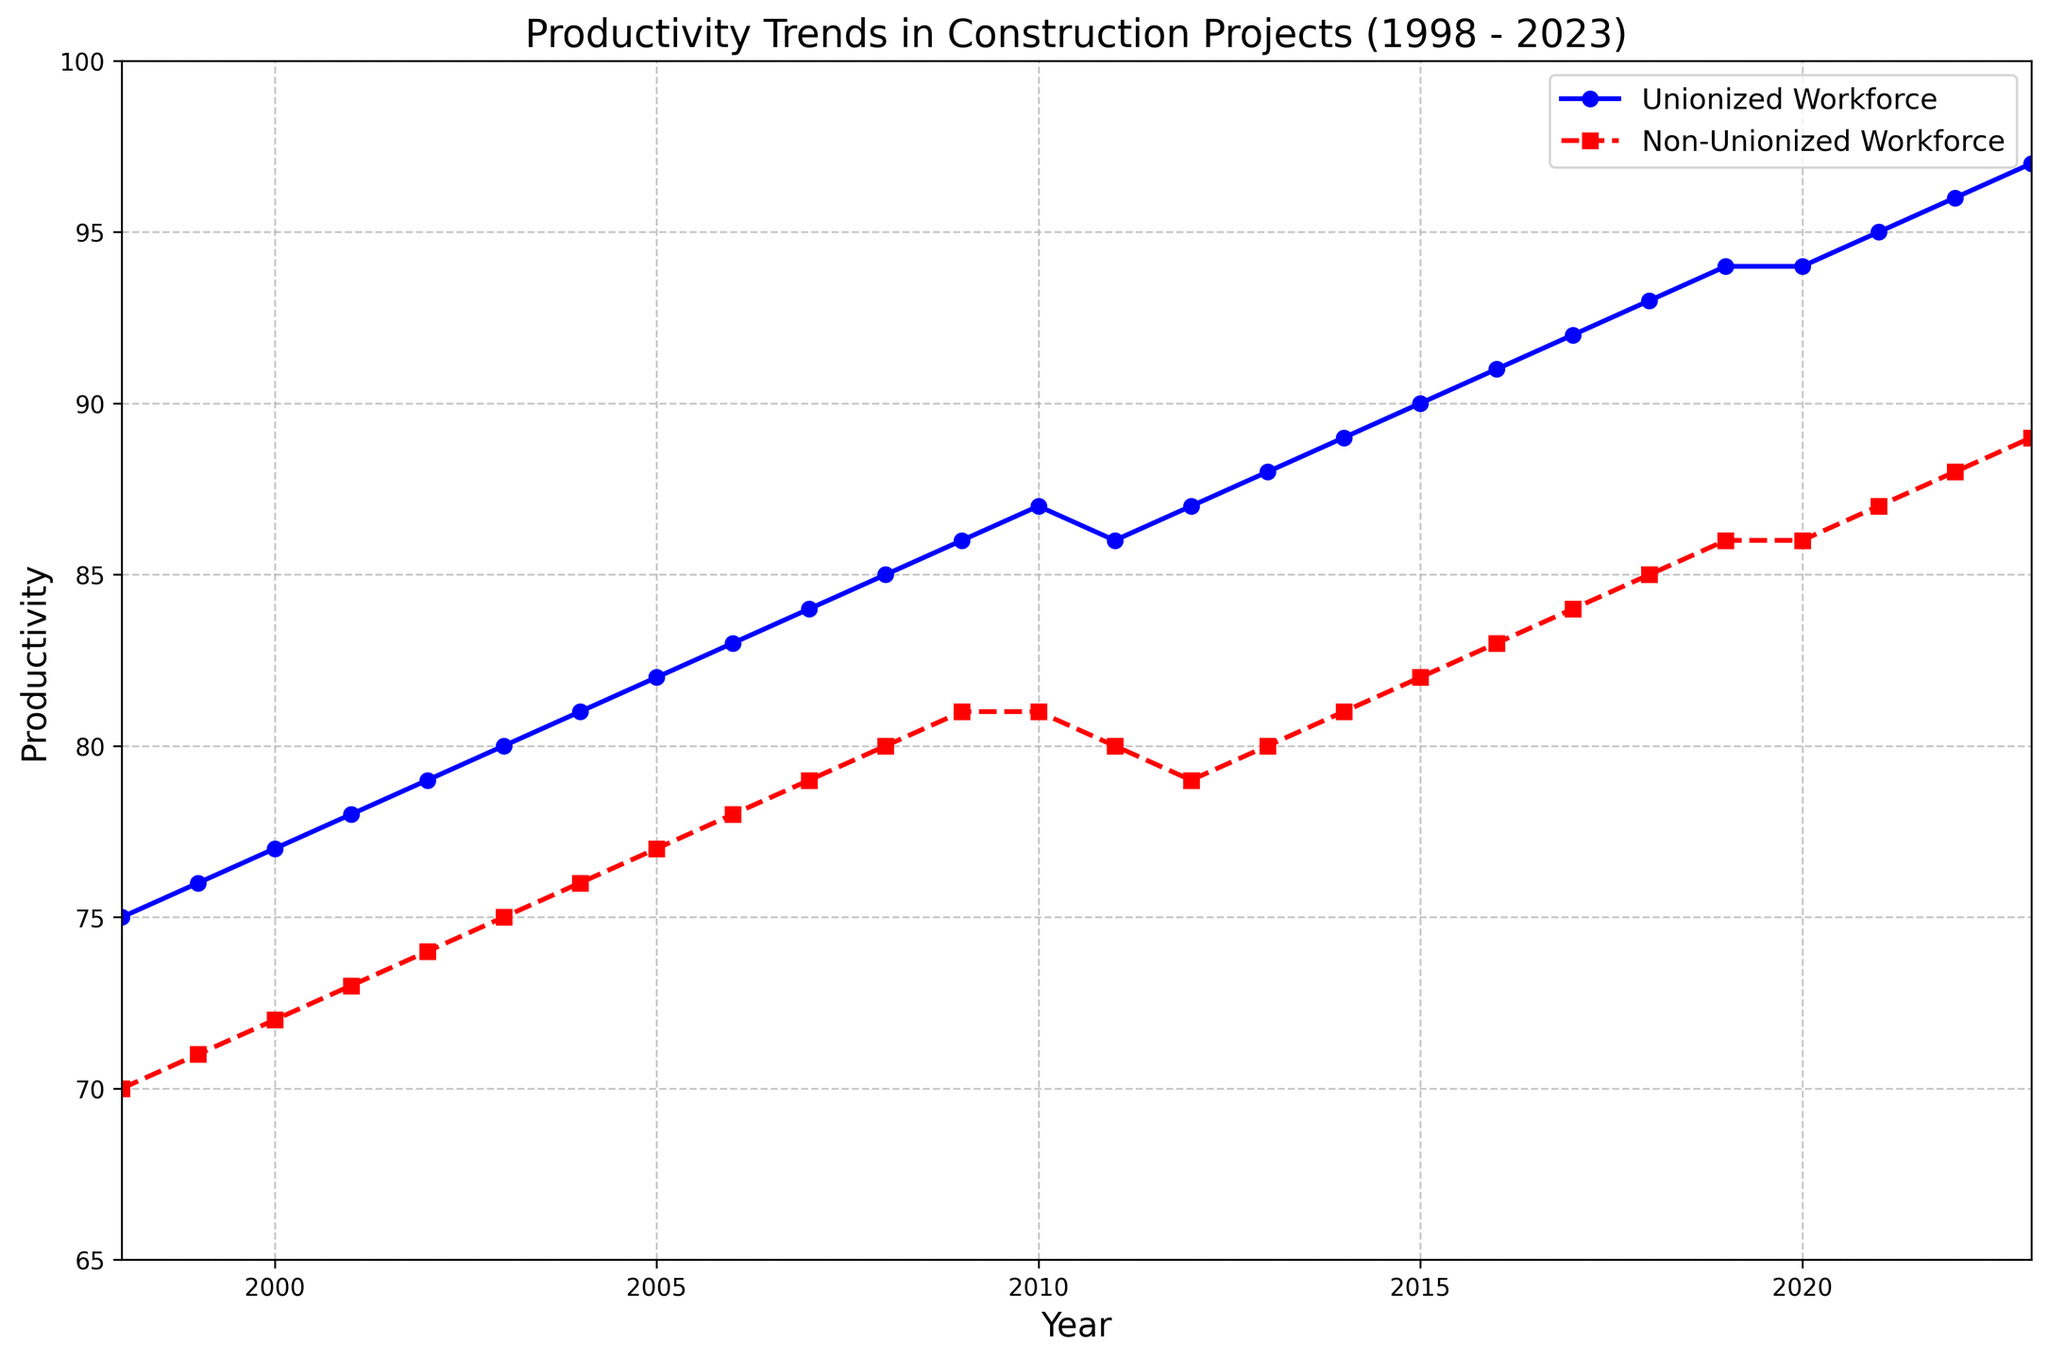What year did the productivity of the unionized workforce surpass 90? In the figure, find the point where the productivity of the unionized workforce first crosses the value of 90 on the y-axis.
Answer: 2016 How did the productivity of non-unionized workers compare to unionized workers in 2023? Look at the values for both unionized and non-unionized productivity in the year 2023. The unionized productivity is higher than the non-unionized productivity.
Answer: Higher Was there any year when the productivity of both workforces was the same? Examine the graph for any year where the lines for unionized and non-unionized workforces meet.
Answer: 2010 What is the average productivity of unionized workers from 2010 to 2020? Calculate the average by summing the unionized productivity values from 2010 to 2020 and dividing by the number of years (11). (87+86+87+88+89+90+91+92+93+94+94) / 11 = 90.09
Answer: 90.09 In which year did unionized worker productivity experience the least growth compared to the previous year between 1998 and 2023? Calculate the differences in unionized productivity between consecutive years and find the smallest difference. The smallest increase is between 2019 and 2020 (94-94=0).
Answer: 2020 How much greater was the productivity of the unionized workforce compared to the non-unionized workforce in 2008? Subtract the non-unionized productivity from the unionized productivity for the year 2008. 85 - 80 = 5.
Answer: 5 What trend can be observed in the productivity of unionized workers from 2011 to 2014? Review the graph from 2011 to 2014 and note the direction of the unionized productivity line (increasing or decreasing). The productivity of unionized workers shows an increasing trend.
Answer: Increasing How does the productivity of non-unionized workers in 2023 compare to unionized workers in 1998? Compare the values of non-unionized productivity in 2023 and unionized productivity in 1998. 89 (2023) vs 75 (1998) shows that non-unionized productivity in 2023 is higher.
Answer: Higher What was the difference in productivity between unionized and non-unionized workforces in the year 2000? Subtract the non-unionized productivity from the unionized productivity for the year 2000. 77 - 72 = 5.
Answer: 5 What is the overall trend in productivity for both unionized and non-unionized workforces over the 25-year period? Examine the overall direction of both productivity lines from 1998 to 2023. Both lines show an upward trend, indicating increasing productivity over time.
Answer: Increasing 